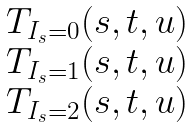<formula> <loc_0><loc_0><loc_500><loc_500>\begin{matrix} T _ { I _ { s } = 0 } ( s , t , u ) \\ T _ { I _ { s } = 1 } ( s , t , u ) \\ T _ { I _ { s } = 2 } ( s , t , u ) \end{matrix}</formula> 